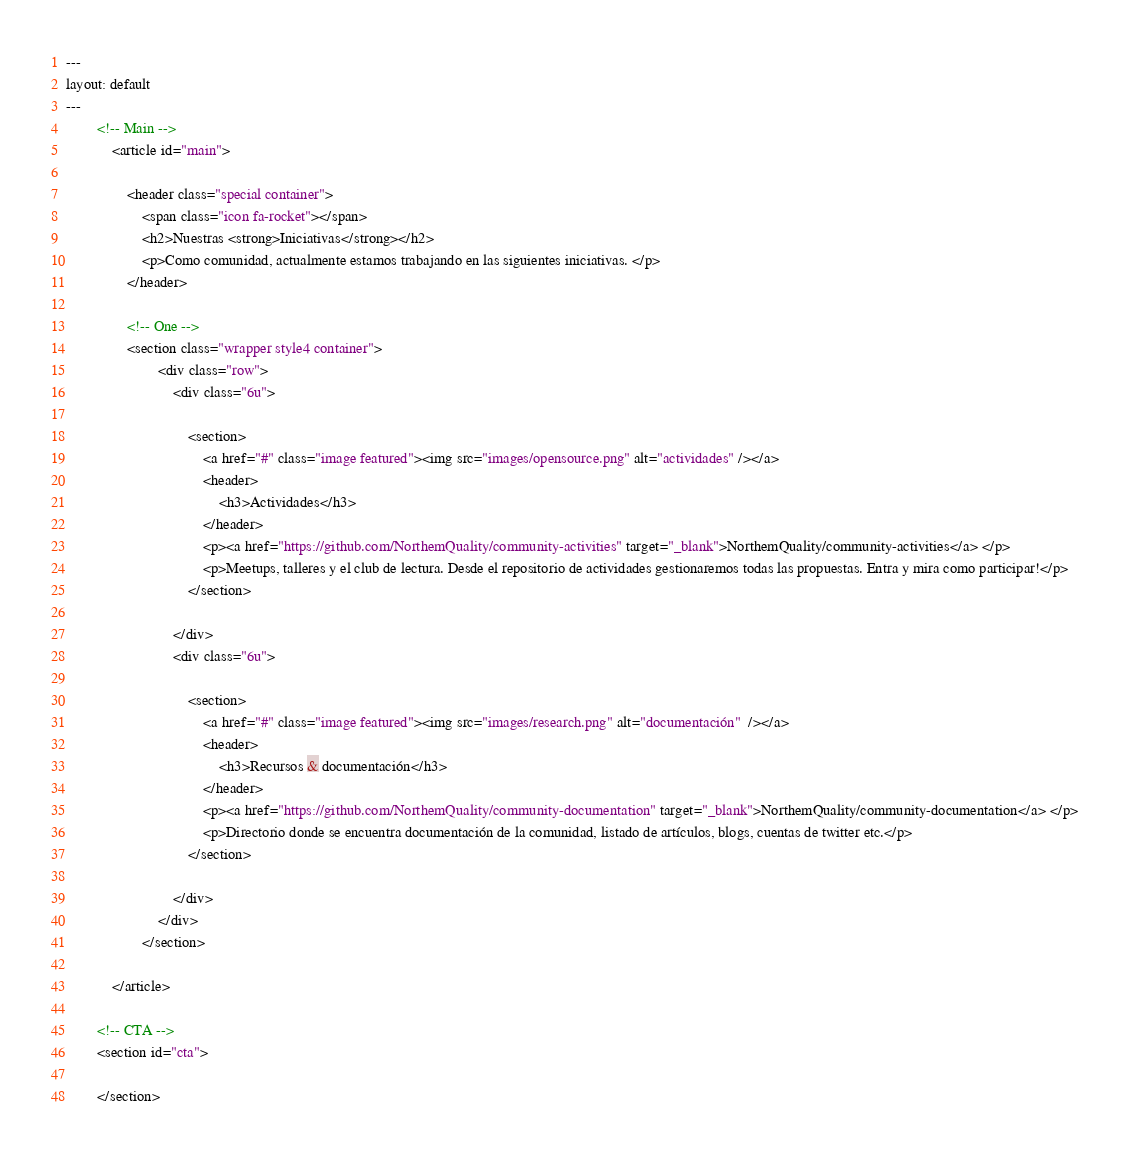<code> <loc_0><loc_0><loc_500><loc_500><_HTML_>---
layout: default
---
		<!-- Main -->
			<article id="main">

				<header class="special container">
					<span class="icon fa-rocket"></span>
					<h2>Nuestras <strong>Iniciativas</strong></h2>
					<p>Como comunidad, actualmente estamos trabajando en las siguientes iniciativas. </p>
				</header>
					
				<!-- One -->
				<section class="wrapper style4 container">
						<div class="row">
							<div class="6u">

								<section>
									<a href="#" class="image featured"><img src="images/opensource.png" alt="actividades" /></a>
									<header>
										<h3>Actividades</h3>
									</header>
									<p><a href="https://github.com/NorthemQuality/community-activities" target="_blank">NorthemQuality/community-activities</a> </p>
									<p>Meetups, talleres y el club de lectura. Desde el repositorio de actividades gestionaremos todas las propuestas. Entra y mira como participar!</p>
								</section>

							</div>
							<div class="6u">

								<section>
									<a href="#" class="image featured"><img src="images/research.png" alt="documentación"  /></a>
									<header>
										<h3>Recursos & documentación</h3>
									</header>
									<p><a href="https://github.com/NorthemQuality/community-documentation" target="_blank">NorthemQuality/community-documentation</a> </p>
									<p>Directorio donde se encuentra documentación de la comunidad, listado de artículos, blogs, cuentas de twitter etc.</p>
								</section>

							</div>
						</div>
					</section>

			</article>

		<!-- CTA -->
		<section id="cta">

		</section></code> 